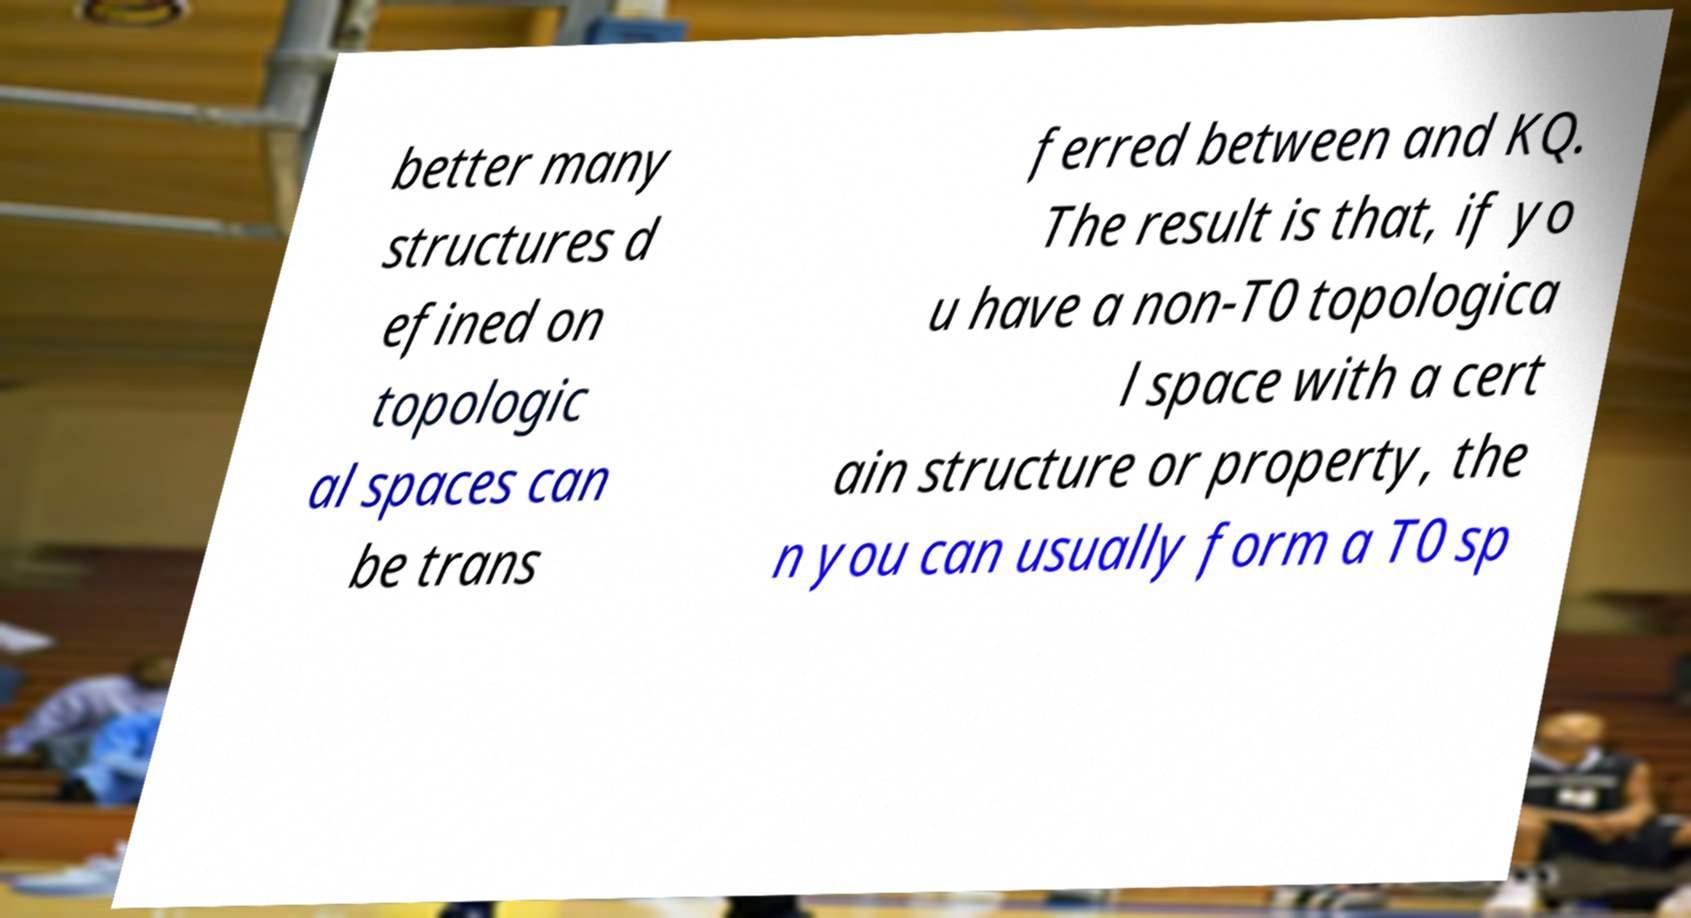Could you assist in decoding the text presented in this image and type it out clearly? better many structures d efined on topologic al spaces can be trans ferred between and KQ. The result is that, if yo u have a non-T0 topologica l space with a cert ain structure or property, the n you can usually form a T0 sp 